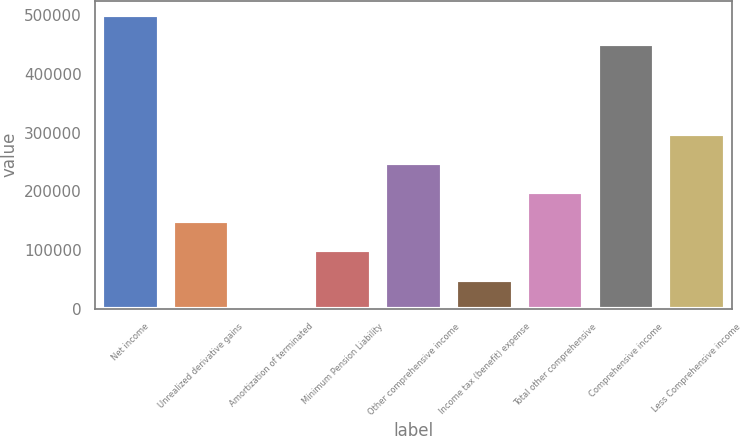<chart> <loc_0><loc_0><loc_500><loc_500><bar_chart><fcel>Net income<fcel>Unrealized derivative gains<fcel>Amortization of terminated<fcel>Minimum Pension Liability<fcel>Other comprehensive income<fcel>Income tax (benefit) expense<fcel>Total other comprehensive<fcel>Comprehensive income<fcel>Less Comprehensive income<nl><fcel>500040<fcel>149056<fcel>336<fcel>99482.4<fcel>248202<fcel>49909.2<fcel>198629<fcel>450467<fcel>297775<nl></chart> 